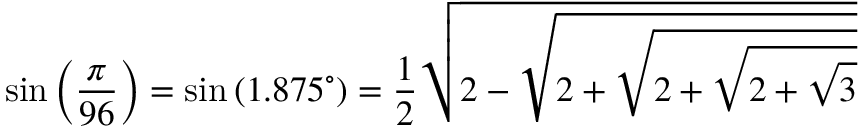Convert formula to latex. <formula><loc_0><loc_0><loc_500><loc_500>\sin \left ( { \frac { \pi } { 9 6 } } \right ) = \sin \left ( 1 . 8 7 5 ^ { \circ } \right ) = { \frac { 1 } { 2 } } { \sqrt { 2 - { \sqrt { 2 + { \sqrt { 2 + { \sqrt { 2 + { \sqrt { 3 } } } } } } } } } }</formula> 